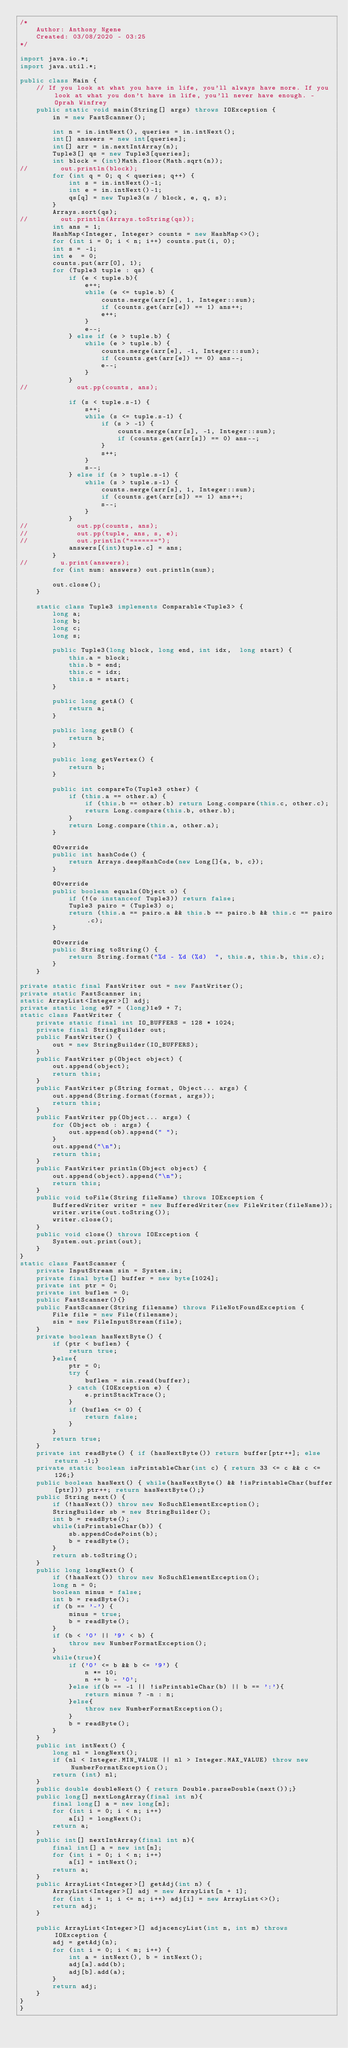<code> <loc_0><loc_0><loc_500><loc_500><_Java_>/*
    Author: Anthony Ngene
    Created: 03/08/2020 - 03:25
*/

import java.io.*;
import java.util.*;

public class Main {
    // If you look at what you have in life, you'll always have more. If you look at what you don't have in life, you'll never have enough. - Oprah Winfrey
    public static void main(String[] args) throws IOException {
        in = new FastScanner();

        int n = in.intNext(), queries = in.intNext();
        int[] answers = new int[queries];
        int[] arr = in.nextIntArray(n);
        Tuple3[] qs = new Tuple3[queries];
        int block = (int)Math.floor(Math.sqrt(n));
//        out.println(block);
        for (int q = 0; q < queries; q++) {
            int s = in.intNext()-1;
            int e = in.intNext()-1;
            qs[q] = new Tuple3(s / block, e, q, s);
        }
        Arrays.sort(qs);
//        out.println(Arrays.toString(qs));
        int ans = 1;
        HashMap<Integer, Integer> counts = new HashMap<>();
        for (int i = 0; i < n; i++) counts.put(i, 0);
        int s = -1;
        int e  = 0;
        counts.put(arr[0], 1);
        for (Tuple3 tuple : qs) {
            if (e < tuple.b){
                e++;
                while (e <= tuple.b) {
                    counts.merge(arr[e], 1, Integer::sum);
                    if (counts.get(arr[e]) == 1) ans++;
                    e++;
                }
                e--;
            } else if (e > tuple.b) {
                while (e > tuple.b) {
                    counts.merge(arr[e], -1, Integer::sum);
                    if (counts.get(arr[e]) == 0) ans--;
                    e--;
                }
            }
//            out.pp(counts, ans);

            if (s < tuple.s-1) {
                s++;
                while (s <= tuple.s-1) {
                    if (s > -1) {
                        counts.merge(arr[s], -1, Integer::sum);
                        if (counts.get(arr[s]) == 0) ans--;
                    }
                    s++;
                }
                s--;
            } else if (s > tuple.s-1) {
                while (s > tuple.s-1) {
                    counts.merge(arr[s], 1, Integer::sum);
                    if (counts.get(arr[s]) == 1) ans++;
                    s--;
                }
            }
//            out.pp(counts, ans);
//            out.pp(tuple, ans, s, e);
//            out.println("=======");
            answers[(int)tuple.c] = ans;
        }
//        u.print(answers);
        for (int num: answers) out.println(num);

        out.close();
    }

    static class Tuple3 implements Comparable<Tuple3> {
        long a;
        long b;
        long c;
        long s;

        public Tuple3(long block, long end, int idx,  long start) {
            this.a = block;
            this.b = end;
            this.c = idx;
            this.s = start;
        }

        public long getA() {
            return a;
        }

        public long getB() {
            return b;
        }

        public long getVertex() {
            return b;
        }

        public int compareTo(Tuple3 other) {
            if (this.a == other.a) {
                if (this.b == other.b) return Long.compare(this.c, other.c);
                return Long.compare(this.b, other.b);
            }
            return Long.compare(this.a, other.a);
        }

        @Override
        public int hashCode() {
            return Arrays.deepHashCode(new Long[]{a, b, c});
        }

        @Override
        public boolean equals(Object o) {
            if (!(o instanceof Tuple3)) return false;
            Tuple3 pairo = (Tuple3) o;
            return (this.a == pairo.a && this.b == pairo.b && this.c == pairo.c);
        }

        @Override
        public String toString() {
            return String.format("%d - %d (%d)  ", this.s, this.b, this.c);
        }
    }

private static final FastWriter out = new FastWriter();
private static FastScanner in;
static ArrayList<Integer>[] adj;
private static long e97 = (long)1e9 + 7;
static class FastWriter {
    private static final int IO_BUFFERS = 128 * 1024;
    private final StringBuilder out;
    public FastWriter() {
        out = new StringBuilder(IO_BUFFERS);
    }
    public FastWriter p(Object object) {
        out.append(object);
        return this;
    }
    public FastWriter p(String format, Object... args) {
        out.append(String.format(format, args));
        return this;
    }
    public FastWriter pp(Object... args) {
        for (Object ob : args) {
            out.append(ob).append(" ");
        }
        out.append("\n");
        return this;
    }
    public FastWriter println(Object object) {
        out.append(object).append("\n");
        return this;
    }
    public void toFile(String fileName) throws IOException {
        BufferedWriter writer = new BufferedWriter(new FileWriter(fileName));
        writer.write(out.toString());
        writer.close();
    }
    public void close() throws IOException {
        System.out.print(out);
    }
}
static class FastScanner {
    private InputStream sin = System.in;
    private final byte[] buffer = new byte[1024];
    private int ptr = 0;
    private int buflen = 0;
    public FastScanner(){}
    public FastScanner(String filename) throws FileNotFoundException {
        File file = new File(filename);
        sin = new FileInputStream(file);
    }
    private boolean hasNextByte() {
        if (ptr < buflen) {
            return true;
        }else{
            ptr = 0;
            try {
                buflen = sin.read(buffer);
            } catch (IOException e) {
                e.printStackTrace();
            }
            if (buflen <= 0) {
                return false;
            }
        }
        return true;
    }
    private int readByte() { if (hasNextByte()) return buffer[ptr++]; else return -1;}
    private static boolean isPrintableChar(int c) { return 33 <= c && c <= 126;}
    public boolean hasNext() { while(hasNextByte() && !isPrintableChar(buffer[ptr])) ptr++; return hasNextByte();}
    public String next() {
        if (!hasNext()) throw new NoSuchElementException();
        StringBuilder sb = new StringBuilder();
        int b = readByte();
        while(isPrintableChar(b)) {
            sb.appendCodePoint(b);
            b = readByte();
        }
        return sb.toString();
    }
    public long longNext() {
        if (!hasNext()) throw new NoSuchElementException();
        long n = 0;
        boolean minus = false;
        int b = readByte();
        if (b == '-') {
            minus = true;
            b = readByte();
        }
        if (b < '0' || '9' < b) {
            throw new NumberFormatException();
        }
        while(true){
            if ('0' <= b && b <= '9') {
                n *= 10;
                n += b - '0';
            }else if(b == -1 || !isPrintableChar(b) || b == ':'){
                return minus ? -n : n;
            }else{
                throw new NumberFormatException();
            }
            b = readByte();
        }
    }
    public int intNext() {
        long nl = longNext();
        if (nl < Integer.MIN_VALUE || nl > Integer.MAX_VALUE) throw new NumberFormatException();
        return (int) nl;
    }
    public double doubleNext() { return Double.parseDouble(next());}
    public long[] nextLongArray(final int n){
        final long[] a = new long[n];
        for (int i = 0; i < n; i++)
            a[i] = longNext();
        return a;
    }
    public int[] nextIntArray(final int n){
        final int[] a = new int[n];
        for (int i = 0; i < n; i++)
            a[i] = intNext();
        return a;
    }
    public ArrayList<Integer>[] getAdj(int n) {
        ArrayList<Integer>[] adj = new ArrayList[n + 1];
        for (int i = 1; i <= n; i++) adj[i] = new ArrayList<>();
        return adj;
    }

    public ArrayList<Integer>[] adjacencyList(int n, int m) throws IOException {
        adj = getAdj(n);
        for (int i = 0; i < m; i++) {
            int a = intNext(), b = intNext();
            adj[a].add(b);
            adj[b].add(a);
        }
        return adj;
    }
}
}
</code> 